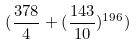Convert formula to latex. <formula><loc_0><loc_0><loc_500><loc_500>( \frac { 3 7 8 } { 4 } + ( \frac { 1 4 3 } { 1 0 } ) ^ { 1 9 6 } )</formula> 